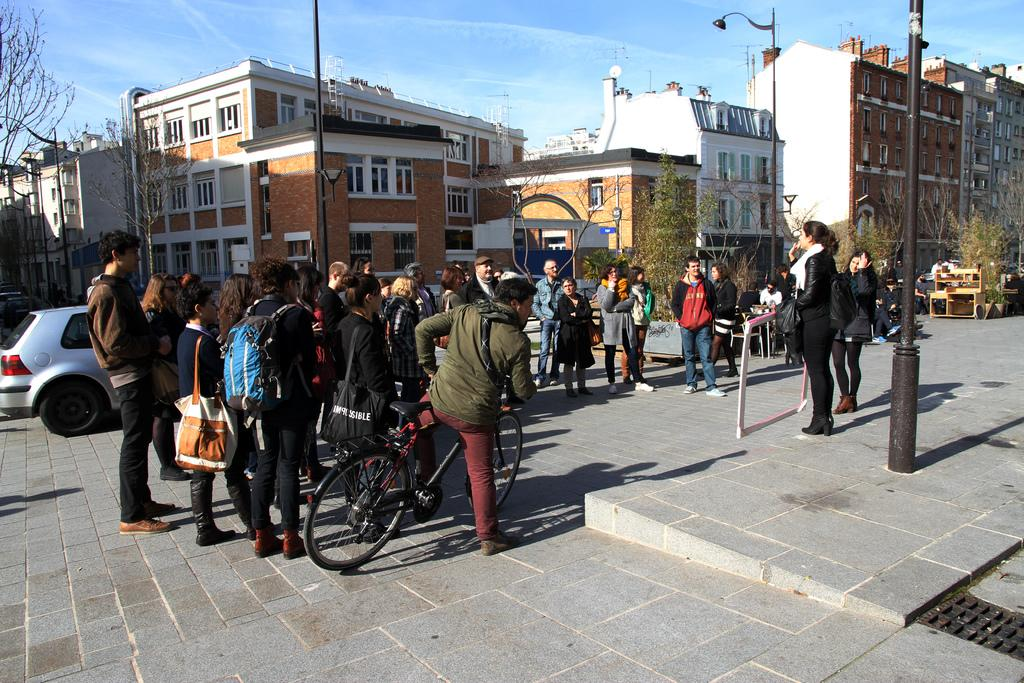What are the people in the image doing? The people in the image are standing on the road. What can be seen in the background of the image? There are buildings and trees visible in the background of the image. What is the condition of the sky in the image? The sky is clear in the image. Can you see a giraffe walking on the road in the image? No, there is no giraffe present in the image. 